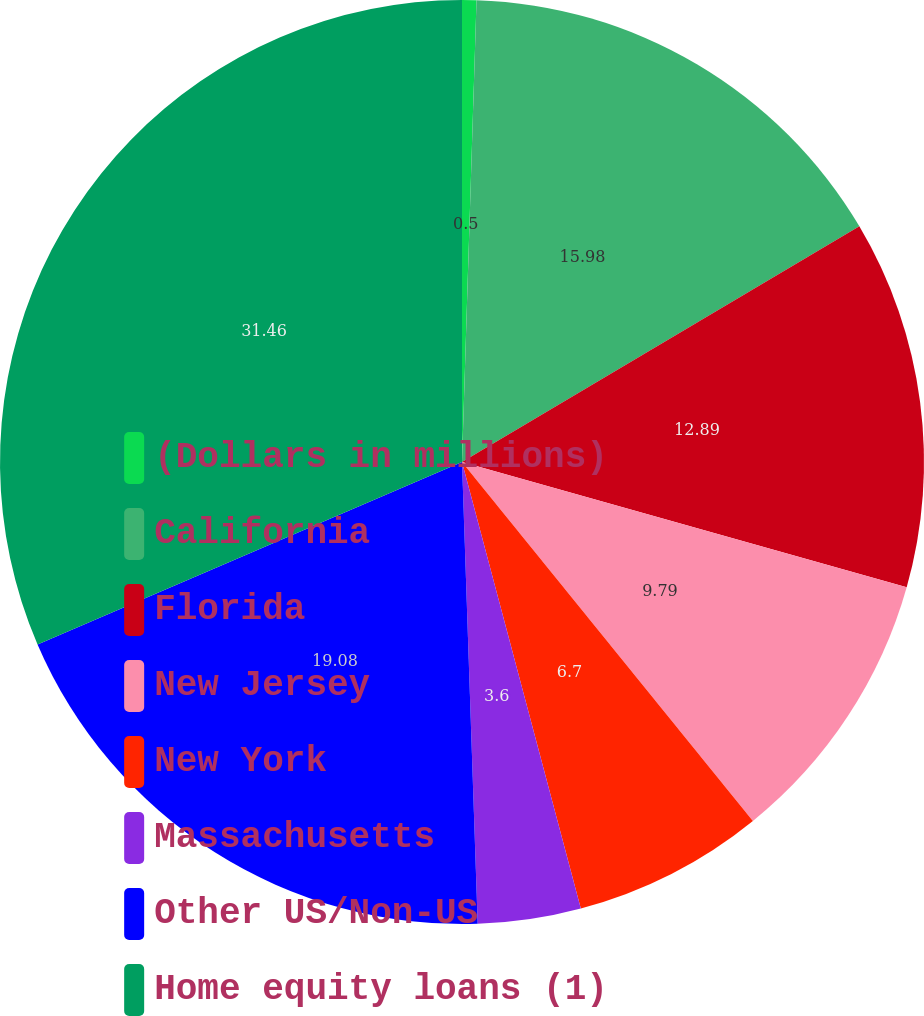Convert chart to OTSL. <chart><loc_0><loc_0><loc_500><loc_500><pie_chart><fcel>(Dollars in millions)<fcel>California<fcel>Florida<fcel>New Jersey<fcel>New York<fcel>Massachusetts<fcel>Other US/Non-US<fcel>Home equity loans (1)<nl><fcel>0.5%<fcel>15.98%<fcel>12.89%<fcel>9.79%<fcel>6.7%<fcel>3.6%<fcel>19.08%<fcel>31.46%<nl></chart> 